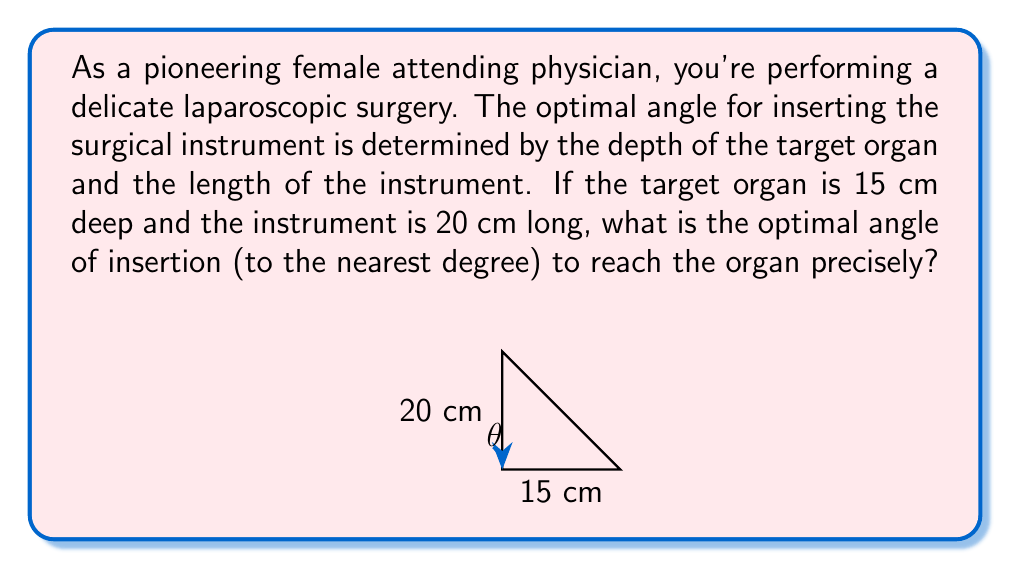Give your solution to this math problem. Let's approach this step-by-step using trigonometry:

1) The situation forms a right-angled triangle, where:
   - The depth of the organ (15 cm) forms the base of the triangle
   - The length of the instrument (20 cm) forms the hypotenuse
   - The angle of insertion ($\theta$) is what we need to find

2) In a right-angled triangle, we can use the inverse sine (arcsin) function to find the angle when we know the opposite side and hypotenuse.

3) The formula is:

   $$\theta = \arcsin(\frac{\text{opposite}}{\text{hypotenuse}})$$

4) Substituting our values:

   $$\theta = \arcsin(\frac{15}{20})$$

5) Simplifying:

   $$\theta = \arcsin(0.75)$$

6) Using a calculator or trigonometric tables:

   $$\theta \approx 48.59°$$

7) Rounding to the nearest degree:

   $$\theta \approx 49°$$

Therefore, the optimal angle of insertion is approximately 49 degrees.
Answer: $49°$ 